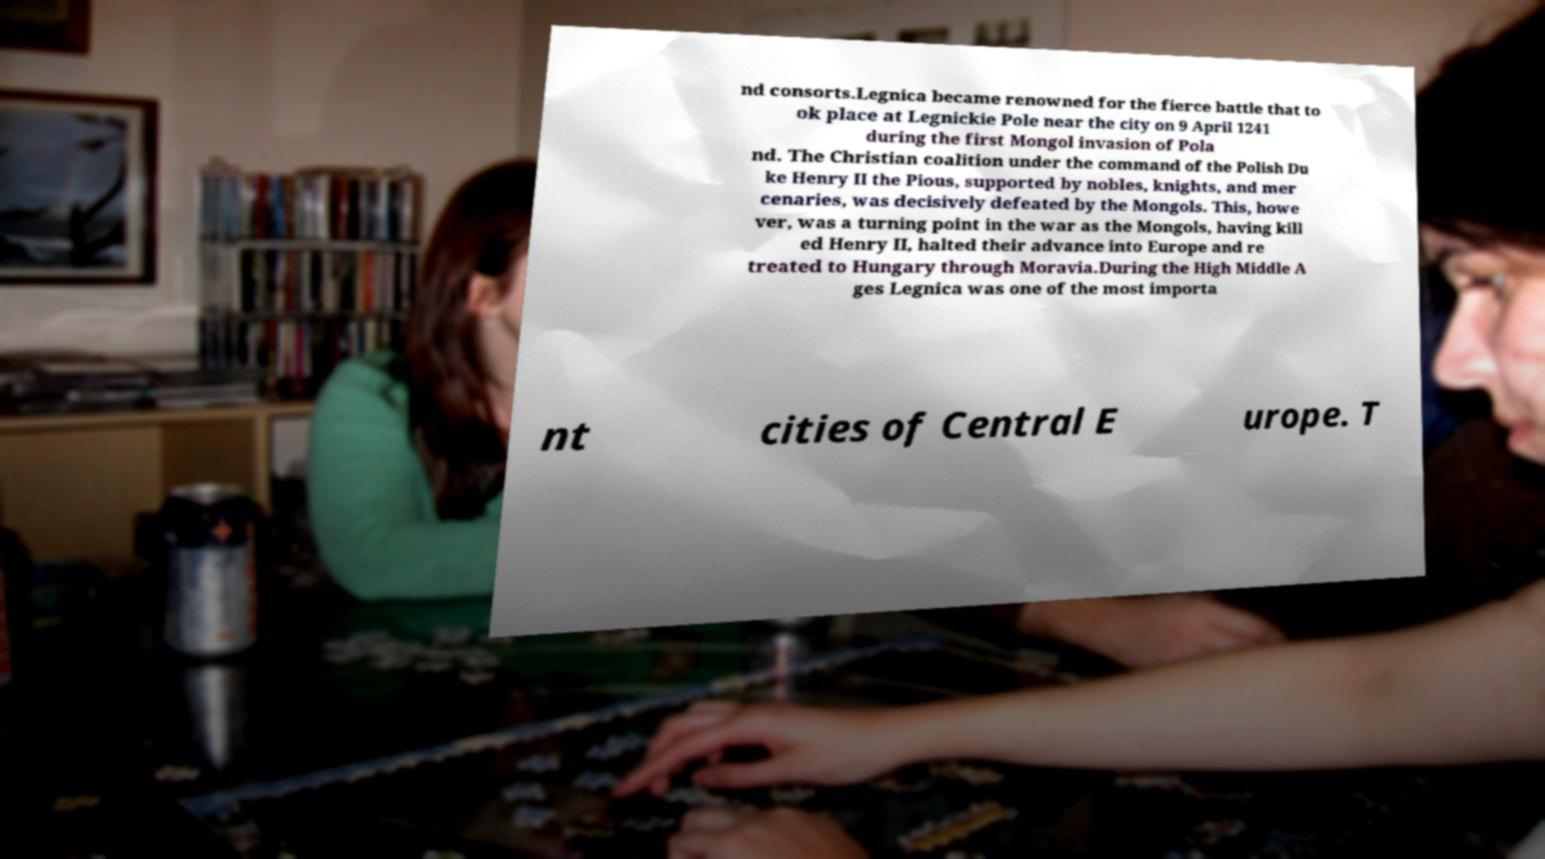What messages or text are displayed in this image? I need them in a readable, typed format. nd consorts.Legnica became renowned for the fierce battle that to ok place at Legnickie Pole near the city on 9 April 1241 during the first Mongol invasion of Pola nd. The Christian coalition under the command of the Polish Du ke Henry II the Pious, supported by nobles, knights, and mer cenaries, was decisively defeated by the Mongols. This, howe ver, was a turning point in the war as the Mongols, having kill ed Henry II, halted their advance into Europe and re treated to Hungary through Moravia.During the High Middle A ges Legnica was one of the most importa nt cities of Central E urope. T 